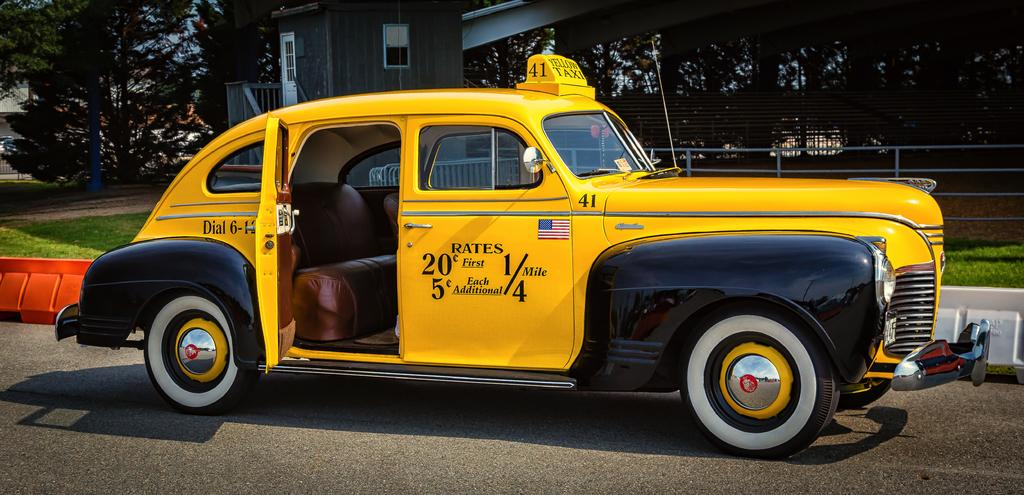What is the main subject of the image? There is a car in the image. Can you describe the car's position in the image? The car is on a surface in the image. What is located behind the car? There are barriers and fencing behind the car. What can be seen in the background of the image? Buildings, grass, and a group of trees are visible in the background. Where are the dinosaurs hiding in the image? There are no dinosaurs present in the image. Can you see any fairies flying around the car in the image? There are no fairies present in the image. 